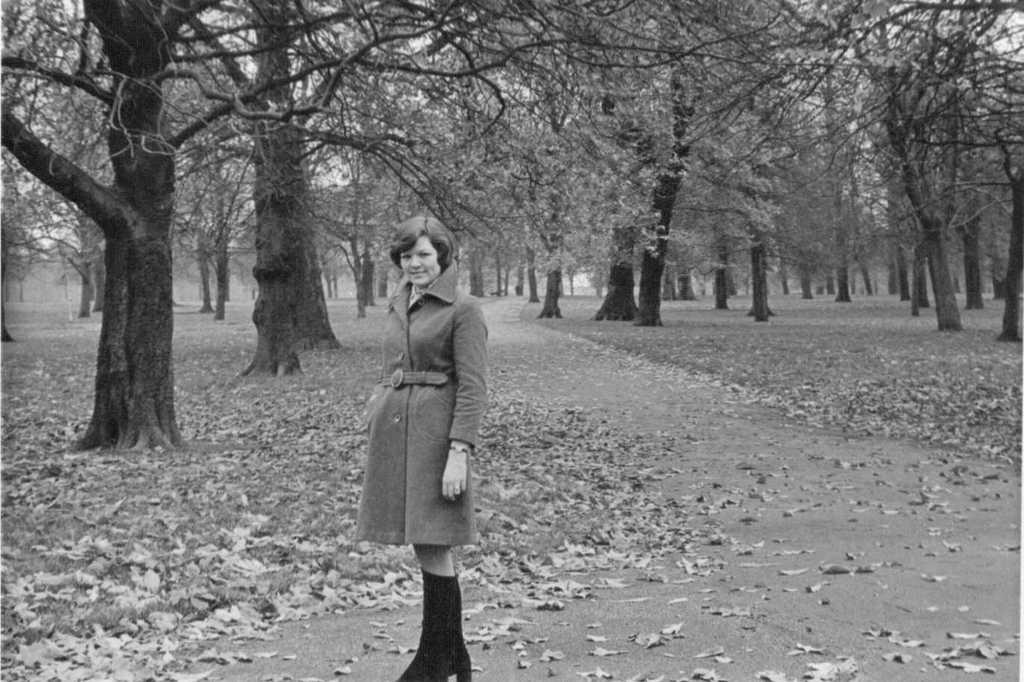Who is present in the image? There is a woman in the image. What is the woman doing in the image? The woman is standing. What is the woman wearing in the image? The woman is wearing a coat and black shoes. What can be seen in the background of the image? There are trees visible in the image. What is present on the ground in the image? Leaves are present on the ground in the image. What type of oven can be seen in the image? There is no oven present in the image. How many trucks are visible in the image? There are no trucks visible in the image. 